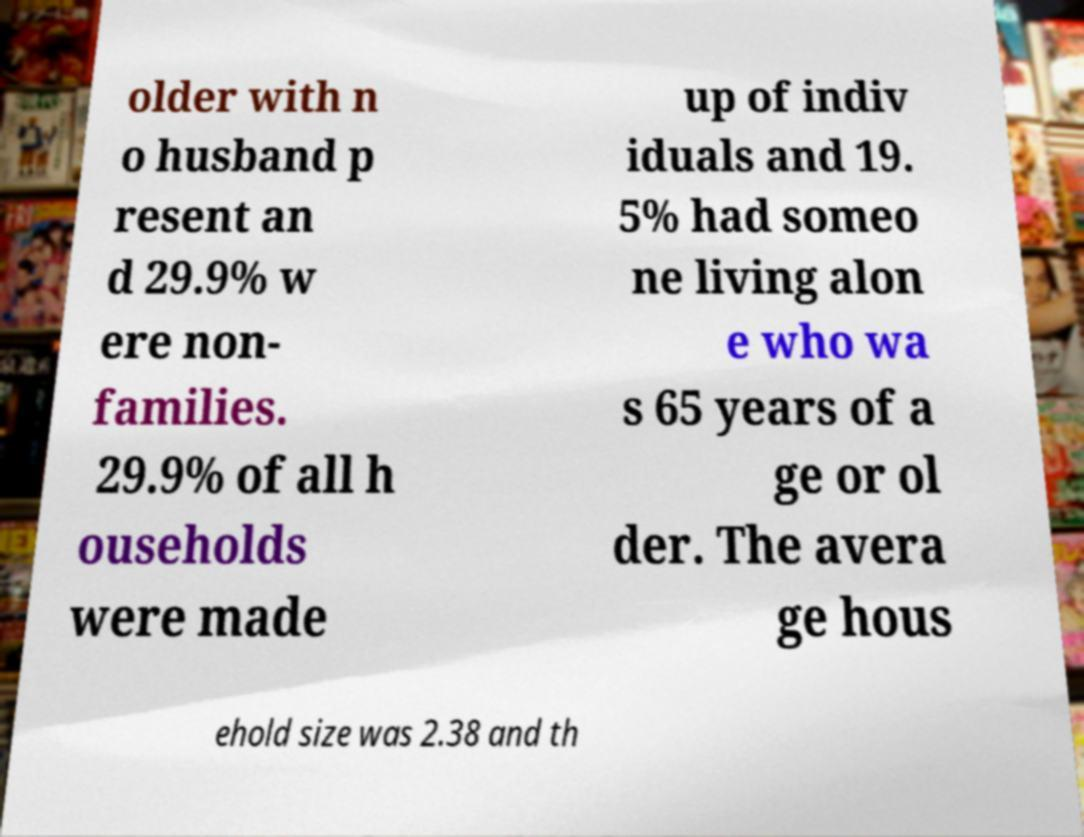There's text embedded in this image that I need extracted. Can you transcribe it verbatim? older with n o husband p resent an d 29.9% w ere non- families. 29.9% of all h ouseholds were made up of indiv iduals and 19. 5% had someo ne living alon e who wa s 65 years of a ge or ol der. The avera ge hous ehold size was 2.38 and th 